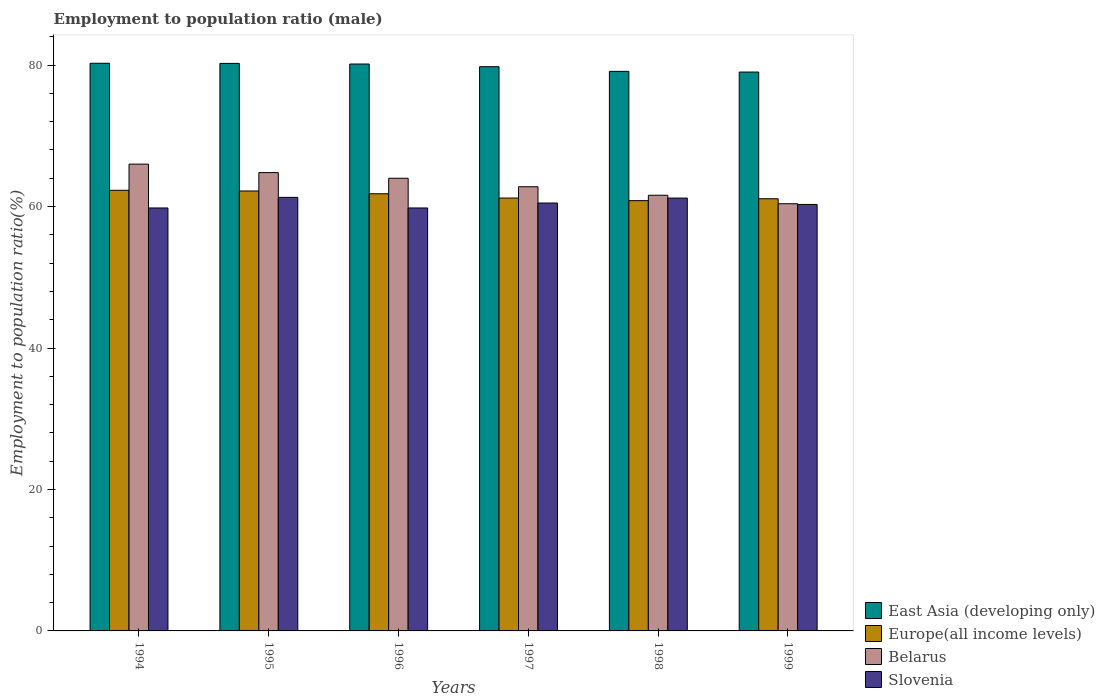How many different coloured bars are there?
Your response must be concise. 4. Are the number of bars per tick equal to the number of legend labels?
Provide a short and direct response. Yes. Are the number of bars on each tick of the X-axis equal?
Offer a terse response. Yes. How many bars are there on the 3rd tick from the left?
Make the answer very short. 4. How many bars are there on the 2nd tick from the right?
Offer a terse response. 4. What is the label of the 1st group of bars from the left?
Your response must be concise. 1994. In how many cases, is the number of bars for a given year not equal to the number of legend labels?
Give a very brief answer. 0. Across all years, what is the maximum employment to population ratio in East Asia (developing only)?
Provide a short and direct response. 80.26. Across all years, what is the minimum employment to population ratio in Belarus?
Provide a short and direct response. 60.4. In which year was the employment to population ratio in East Asia (developing only) maximum?
Offer a very short reply. 1994. What is the total employment to population ratio in Europe(all income levels) in the graph?
Provide a succinct answer. 369.45. What is the difference between the employment to population ratio in Europe(all income levels) in 1998 and that in 1999?
Offer a terse response. -0.27. What is the average employment to population ratio in Slovenia per year?
Keep it short and to the point. 60.48. In the year 1998, what is the difference between the employment to population ratio in Belarus and employment to population ratio in East Asia (developing only)?
Keep it short and to the point. -17.51. What is the ratio of the employment to population ratio in Slovenia in 1995 to that in 1996?
Keep it short and to the point. 1.03. Is the difference between the employment to population ratio in Belarus in 1996 and 1998 greater than the difference between the employment to population ratio in East Asia (developing only) in 1996 and 1998?
Make the answer very short. Yes. What is the difference between the highest and the second highest employment to population ratio in Europe(all income levels)?
Your response must be concise. 0.1. What is the difference between the highest and the lowest employment to population ratio in Belarus?
Make the answer very short. 5.6. In how many years, is the employment to population ratio in Europe(all income levels) greater than the average employment to population ratio in Europe(all income levels) taken over all years?
Ensure brevity in your answer.  3. Is the sum of the employment to population ratio in Europe(all income levels) in 1994 and 1996 greater than the maximum employment to population ratio in Slovenia across all years?
Offer a terse response. Yes. What does the 1st bar from the left in 1999 represents?
Provide a succinct answer. East Asia (developing only). What does the 2nd bar from the right in 1996 represents?
Give a very brief answer. Belarus. Is it the case that in every year, the sum of the employment to population ratio in East Asia (developing only) and employment to population ratio in Belarus is greater than the employment to population ratio in Europe(all income levels)?
Your answer should be very brief. Yes. Are all the bars in the graph horizontal?
Offer a very short reply. No. How many years are there in the graph?
Your response must be concise. 6. What is the difference between two consecutive major ticks on the Y-axis?
Your answer should be compact. 20. Where does the legend appear in the graph?
Offer a terse response. Bottom right. How many legend labels are there?
Ensure brevity in your answer.  4. What is the title of the graph?
Give a very brief answer. Employment to population ratio (male). Does "Papua New Guinea" appear as one of the legend labels in the graph?
Your response must be concise. No. What is the label or title of the X-axis?
Keep it short and to the point. Years. What is the Employment to population ratio(%) of East Asia (developing only) in 1994?
Your answer should be very brief. 80.26. What is the Employment to population ratio(%) of Europe(all income levels) in 1994?
Offer a very short reply. 62.3. What is the Employment to population ratio(%) of Belarus in 1994?
Provide a succinct answer. 66. What is the Employment to population ratio(%) of Slovenia in 1994?
Your response must be concise. 59.8. What is the Employment to population ratio(%) of East Asia (developing only) in 1995?
Keep it short and to the point. 80.24. What is the Employment to population ratio(%) of Europe(all income levels) in 1995?
Offer a very short reply. 62.2. What is the Employment to population ratio(%) of Belarus in 1995?
Your response must be concise. 64.8. What is the Employment to population ratio(%) in Slovenia in 1995?
Ensure brevity in your answer.  61.3. What is the Employment to population ratio(%) in East Asia (developing only) in 1996?
Your response must be concise. 80.15. What is the Employment to population ratio(%) of Europe(all income levels) in 1996?
Give a very brief answer. 61.81. What is the Employment to population ratio(%) in Belarus in 1996?
Offer a very short reply. 64. What is the Employment to population ratio(%) of Slovenia in 1996?
Your answer should be very brief. 59.8. What is the Employment to population ratio(%) of East Asia (developing only) in 1997?
Offer a terse response. 79.78. What is the Employment to population ratio(%) of Europe(all income levels) in 1997?
Your response must be concise. 61.2. What is the Employment to population ratio(%) of Belarus in 1997?
Offer a very short reply. 62.8. What is the Employment to population ratio(%) of Slovenia in 1997?
Your answer should be very brief. 60.5. What is the Employment to population ratio(%) in East Asia (developing only) in 1998?
Your answer should be very brief. 79.11. What is the Employment to population ratio(%) in Europe(all income levels) in 1998?
Offer a terse response. 60.83. What is the Employment to population ratio(%) in Belarus in 1998?
Offer a terse response. 61.6. What is the Employment to population ratio(%) in Slovenia in 1998?
Make the answer very short. 61.2. What is the Employment to population ratio(%) in East Asia (developing only) in 1999?
Make the answer very short. 79.02. What is the Employment to population ratio(%) in Europe(all income levels) in 1999?
Make the answer very short. 61.1. What is the Employment to population ratio(%) in Belarus in 1999?
Keep it short and to the point. 60.4. What is the Employment to population ratio(%) in Slovenia in 1999?
Offer a terse response. 60.3. Across all years, what is the maximum Employment to population ratio(%) of East Asia (developing only)?
Give a very brief answer. 80.26. Across all years, what is the maximum Employment to population ratio(%) of Europe(all income levels)?
Make the answer very short. 62.3. Across all years, what is the maximum Employment to population ratio(%) of Belarus?
Provide a short and direct response. 66. Across all years, what is the maximum Employment to population ratio(%) of Slovenia?
Offer a very short reply. 61.3. Across all years, what is the minimum Employment to population ratio(%) of East Asia (developing only)?
Your answer should be very brief. 79.02. Across all years, what is the minimum Employment to population ratio(%) of Europe(all income levels)?
Make the answer very short. 60.83. Across all years, what is the minimum Employment to population ratio(%) in Belarus?
Keep it short and to the point. 60.4. Across all years, what is the minimum Employment to population ratio(%) in Slovenia?
Your response must be concise. 59.8. What is the total Employment to population ratio(%) in East Asia (developing only) in the graph?
Offer a very short reply. 478.56. What is the total Employment to population ratio(%) of Europe(all income levels) in the graph?
Provide a short and direct response. 369.45. What is the total Employment to population ratio(%) in Belarus in the graph?
Ensure brevity in your answer.  379.6. What is the total Employment to population ratio(%) in Slovenia in the graph?
Your response must be concise. 362.9. What is the difference between the Employment to population ratio(%) in East Asia (developing only) in 1994 and that in 1995?
Your answer should be compact. 0.02. What is the difference between the Employment to population ratio(%) in Europe(all income levels) in 1994 and that in 1995?
Make the answer very short. 0.1. What is the difference between the Employment to population ratio(%) in Slovenia in 1994 and that in 1995?
Make the answer very short. -1.5. What is the difference between the Employment to population ratio(%) in East Asia (developing only) in 1994 and that in 1996?
Provide a short and direct response. 0.11. What is the difference between the Employment to population ratio(%) in Europe(all income levels) in 1994 and that in 1996?
Provide a short and direct response. 0.49. What is the difference between the Employment to population ratio(%) of East Asia (developing only) in 1994 and that in 1997?
Give a very brief answer. 0.48. What is the difference between the Employment to population ratio(%) of Europe(all income levels) in 1994 and that in 1997?
Make the answer very short. 1.1. What is the difference between the Employment to population ratio(%) in Belarus in 1994 and that in 1997?
Your answer should be compact. 3.2. What is the difference between the Employment to population ratio(%) of East Asia (developing only) in 1994 and that in 1998?
Offer a terse response. 1.15. What is the difference between the Employment to population ratio(%) in Europe(all income levels) in 1994 and that in 1998?
Ensure brevity in your answer.  1.47. What is the difference between the Employment to population ratio(%) in Belarus in 1994 and that in 1998?
Ensure brevity in your answer.  4.4. What is the difference between the Employment to population ratio(%) of Slovenia in 1994 and that in 1998?
Your answer should be compact. -1.4. What is the difference between the Employment to population ratio(%) of East Asia (developing only) in 1994 and that in 1999?
Provide a succinct answer. 1.24. What is the difference between the Employment to population ratio(%) in Europe(all income levels) in 1994 and that in 1999?
Keep it short and to the point. 1.2. What is the difference between the Employment to population ratio(%) in East Asia (developing only) in 1995 and that in 1996?
Ensure brevity in your answer.  0.09. What is the difference between the Employment to population ratio(%) in Europe(all income levels) in 1995 and that in 1996?
Offer a very short reply. 0.39. What is the difference between the Employment to population ratio(%) of Slovenia in 1995 and that in 1996?
Make the answer very short. 1.5. What is the difference between the Employment to population ratio(%) of East Asia (developing only) in 1995 and that in 1997?
Give a very brief answer. 0.46. What is the difference between the Employment to population ratio(%) of Europe(all income levels) in 1995 and that in 1997?
Provide a succinct answer. 1. What is the difference between the Employment to population ratio(%) in East Asia (developing only) in 1995 and that in 1998?
Offer a terse response. 1.13. What is the difference between the Employment to population ratio(%) in Europe(all income levels) in 1995 and that in 1998?
Offer a very short reply. 1.37. What is the difference between the Employment to population ratio(%) in Slovenia in 1995 and that in 1998?
Keep it short and to the point. 0.1. What is the difference between the Employment to population ratio(%) in East Asia (developing only) in 1995 and that in 1999?
Give a very brief answer. 1.22. What is the difference between the Employment to population ratio(%) in Europe(all income levels) in 1995 and that in 1999?
Your response must be concise. 1.1. What is the difference between the Employment to population ratio(%) in Belarus in 1995 and that in 1999?
Offer a very short reply. 4.4. What is the difference between the Employment to population ratio(%) of East Asia (developing only) in 1996 and that in 1997?
Ensure brevity in your answer.  0.38. What is the difference between the Employment to population ratio(%) in Europe(all income levels) in 1996 and that in 1997?
Provide a succinct answer. 0.61. What is the difference between the Employment to population ratio(%) in East Asia (developing only) in 1996 and that in 1998?
Provide a succinct answer. 1.04. What is the difference between the Employment to population ratio(%) of Europe(all income levels) in 1996 and that in 1998?
Your response must be concise. 0.97. What is the difference between the Employment to population ratio(%) in East Asia (developing only) in 1996 and that in 1999?
Your answer should be very brief. 1.14. What is the difference between the Employment to population ratio(%) of Europe(all income levels) in 1996 and that in 1999?
Your answer should be compact. 0.71. What is the difference between the Employment to population ratio(%) of Belarus in 1996 and that in 1999?
Make the answer very short. 3.6. What is the difference between the Employment to population ratio(%) of East Asia (developing only) in 1997 and that in 1998?
Your answer should be compact. 0.66. What is the difference between the Employment to population ratio(%) of Europe(all income levels) in 1997 and that in 1998?
Offer a very short reply. 0.37. What is the difference between the Employment to population ratio(%) in Belarus in 1997 and that in 1998?
Keep it short and to the point. 1.2. What is the difference between the Employment to population ratio(%) of East Asia (developing only) in 1997 and that in 1999?
Keep it short and to the point. 0.76. What is the difference between the Employment to population ratio(%) of Europe(all income levels) in 1997 and that in 1999?
Provide a short and direct response. 0.1. What is the difference between the Employment to population ratio(%) in Belarus in 1997 and that in 1999?
Your answer should be compact. 2.4. What is the difference between the Employment to population ratio(%) of Slovenia in 1997 and that in 1999?
Your answer should be very brief. 0.2. What is the difference between the Employment to population ratio(%) in East Asia (developing only) in 1998 and that in 1999?
Provide a short and direct response. 0.1. What is the difference between the Employment to population ratio(%) in Europe(all income levels) in 1998 and that in 1999?
Offer a very short reply. -0.27. What is the difference between the Employment to population ratio(%) in Slovenia in 1998 and that in 1999?
Keep it short and to the point. 0.9. What is the difference between the Employment to population ratio(%) in East Asia (developing only) in 1994 and the Employment to population ratio(%) in Europe(all income levels) in 1995?
Your answer should be very brief. 18.06. What is the difference between the Employment to population ratio(%) in East Asia (developing only) in 1994 and the Employment to population ratio(%) in Belarus in 1995?
Offer a terse response. 15.46. What is the difference between the Employment to population ratio(%) in East Asia (developing only) in 1994 and the Employment to population ratio(%) in Slovenia in 1995?
Offer a very short reply. 18.96. What is the difference between the Employment to population ratio(%) in Europe(all income levels) in 1994 and the Employment to population ratio(%) in Belarus in 1995?
Your answer should be compact. -2.5. What is the difference between the Employment to population ratio(%) of Europe(all income levels) in 1994 and the Employment to population ratio(%) of Slovenia in 1995?
Offer a very short reply. 1. What is the difference between the Employment to population ratio(%) in East Asia (developing only) in 1994 and the Employment to population ratio(%) in Europe(all income levels) in 1996?
Keep it short and to the point. 18.45. What is the difference between the Employment to population ratio(%) in East Asia (developing only) in 1994 and the Employment to population ratio(%) in Belarus in 1996?
Offer a terse response. 16.26. What is the difference between the Employment to population ratio(%) in East Asia (developing only) in 1994 and the Employment to population ratio(%) in Slovenia in 1996?
Your response must be concise. 20.46. What is the difference between the Employment to population ratio(%) in Europe(all income levels) in 1994 and the Employment to population ratio(%) in Belarus in 1996?
Keep it short and to the point. -1.7. What is the difference between the Employment to population ratio(%) in Europe(all income levels) in 1994 and the Employment to population ratio(%) in Slovenia in 1996?
Provide a succinct answer. 2.5. What is the difference between the Employment to population ratio(%) of East Asia (developing only) in 1994 and the Employment to population ratio(%) of Europe(all income levels) in 1997?
Keep it short and to the point. 19.06. What is the difference between the Employment to population ratio(%) in East Asia (developing only) in 1994 and the Employment to population ratio(%) in Belarus in 1997?
Offer a very short reply. 17.46. What is the difference between the Employment to population ratio(%) of East Asia (developing only) in 1994 and the Employment to population ratio(%) of Slovenia in 1997?
Offer a terse response. 19.76. What is the difference between the Employment to population ratio(%) of Europe(all income levels) in 1994 and the Employment to population ratio(%) of Belarus in 1997?
Your answer should be very brief. -0.5. What is the difference between the Employment to population ratio(%) of Europe(all income levels) in 1994 and the Employment to population ratio(%) of Slovenia in 1997?
Provide a short and direct response. 1.8. What is the difference between the Employment to population ratio(%) in East Asia (developing only) in 1994 and the Employment to population ratio(%) in Europe(all income levels) in 1998?
Give a very brief answer. 19.43. What is the difference between the Employment to population ratio(%) of East Asia (developing only) in 1994 and the Employment to population ratio(%) of Belarus in 1998?
Your answer should be compact. 18.66. What is the difference between the Employment to population ratio(%) of East Asia (developing only) in 1994 and the Employment to population ratio(%) of Slovenia in 1998?
Offer a very short reply. 19.06. What is the difference between the Employment to population ratio(%) of Europe(all income levels) in 1994 and the Employment to population ratio(%) of Belarus in 1998?
Give a very brief answer. 0.7. What is the difference between the Employment to population ratio(%) of Europe(all income levels) in 1994 and the Employment to population ratio(%) of Slovenia in 1998?
Make the answer very short. 1.1. What is the difference between the Employment to population ratio(%) of Belarus in 1994 and the Employment to population ratio(%) of Slovenia in 1998?
Provide a succinct answer. 4.8. What is the difference between the Employment to population ratio(%) in East Asia (developing only) in 1994 and the Employment to population ratio(%) in Europe(all income levels) in 1999?
Offer a very short reply. 19.16. What is the difference between the Employment to population ratio(%) in East Asia (developing only) in 1994 and the Employment to population ratio(%) in Belarus in 1999?
Your answer should be very brief. 19.86. What is the difference between the Employment to population ratio(%) of East Asia (developing only) in 1994 and the Employment to population ratio(%) of Slovenia in 1999?
Provide a short and direct response. 19.96. What is the difference between the Employment to population ratio(%) in Europe(all income levels) in 1994 and the Employment to population ratio(%) in Belarus in 1999?
Make the answer very short. 1.9. What is the difference between the Employment to population ratio(%) in Europe(all income levels) in 1994 and the Employment to population ratio(%) in Slovenia in 1999?
Provide a succinct answer. 2. What is the difference between the Employment to population ratio(%) of East Asia (developing only) in 1995 and the Employment to population ratio(%) of Europe(all income levels) in 1996?
Make the answer very short. 18.43. What is the difference between the Employment to population ratio(%) of East Asia (developing only) in 1995 and the Employment to population ratio(%) of Belarus in 1996?
Your answer should be compact. 16.24. What is the difference between the Employment to population ratio(%) of East Asia (developing only) in 1995 and the Employment to population ratio(%) of Slovenia in 1996?
Your answer should be very brief. 20.44. What is the difference between the Employment to population ratio(%) of Europe(all income levels) in 1995 and the Employment to population ratio(%) of Belarus in 1996?
Your response must be concise. -1.8. What is the difference between the Employment to population ratio(%) in Europe(all income levels) in 1995 and the Employment to population ratio(%) in Slovenia in 1996?
Your answer should be compact. 2.4. What is the difference between the Employment to population ratio(%) of Belarus in 1995 and the Employment to population ratio(%) of Slovenia in 1996?
Keep it short and to the point. 5. What is the difference between the Employment to population ratio(%) of East Asia (developing only) in 1995 and the Employment to population ratio(%) of Europe(all income levels) in 1997?
Your response must be concise. 19.04. What is the difference between the Employment to population ratio(%) in East Asia (developing only) in 1995 and the Employment to population ratio(%) in Belarus in 1997?
Offer a very short reply. 17.44. What is the difference between the Employment to population ratio(%) in East Asia (developing only) in 1995 and the Employment to population ratio(%) in Slovenia in 1997?
Give a very brief answer. 19.74. What is the difference between the Employment to population ratio(%) of Europe(all income levels) in 1995 and the Employment to population ratio(%) of Belarus in 1997?
Give a very brief answer. -0.6. What is the difference between the Employment to population ratio(%) of Europe(all income levels) in 1995 and the Employment to population ratio(%) of Slovenia in 1997?
Your answer should be compact. 1.7. What is the difference between the Employment to population ratio(%) of East Asia (developing only) in 1995 and the Employment to population ratio(%) of Europe(all income levels) in 1998?
Ensure brevity in your answer.  19.4. What is the difference between the Employment to population ratio(%) in East Asia (developing only) in 1995 and the Employment to population ratio(%) in Belarus in 1998?
Your answer should be compact. 18.64. What is the difference between the Employment to population ratio(%) of East Asia (developing only) in 1995 and the Employment to population ratio(%) of Slovenia in 1998?
Your answer should be very brief. 19.04. What is the difference between the Employment to population ratio(%) of Europe(all income levels) in 1995 and the Employment to population ratio(%) of Belarus in 1998?
Provide a short and direct response. 0.6. What is the difference between the Employment to population ratio(%) in Belarus in 1995 and the Employment to population ratio(%) in Slovenia in 1998?
Your answer should be compact. 3.6. What is the difference between the Employment to population ratio(%) in East Asia (developing only) in 1995 and the Employment to population ratio(%) in Europe(all income levels) in 1999?
Offer a very short reply. 19.14. What is the difference between the Employment to population ratio(%) of East Asia (developing only) in 1995 and the Employment to population ratio(%) of Belarus in 1999?
Offer a terse response. 19.84. What is the difference between the Employment to population ratio(%) of East Asia (developing only) in 1995 and the Employment to population ratio(%) of Slovenia in 1999?
Offer a very short reply. 19.94. What is the difference between the Employment to population ratio(%) of Europe(all income levels) in 1995 and the Employment to population ratio(%) of Belarus in 1999?
Your response must be concise. 1.8. What is the difference between the Employment to population ratio(%) in Europe(all income levels) in 1995 and the Employment to population ratio(%) in Slovenia in 1999?
Provide a succinct answer. 1.9. What is the difference between the Employment to population ratio(%) of Belarus in 1995 and the Employment to population ratio(%) of Slovenia in 1999?
Offer a terse response. 4.5. What is the difference between the Employment to population ratio(%) of East Asia (developing only) in 1996 and the Employment to population ratio(%) of Europe(all income levels) in 1997?
Provide a short and direct response. 18.95. What is the difference between the Employment to population ratio(%) of East Asia (developing only) in 1996 and the Employment to population ratio(%) of Belarus in 1997?
Give a very brief answer. 17.35. What is the difference between the Employment to population ratio(%) in East Asia (developing only) in 1996 and the Employment to population ratio(%) in Slovenia in 1997?
Offer a terse response. 19.65. What is the difference between the Employment to population ratio(%) of Europe(all income levels) in 1996 and the Employment to population ratio(%) of Belarus in 1997?
Keep it short and to the point. -0.99. What is the difference between the Employment to population ratio(%) of Europe(all income levels) in 1996 and the Employment to population ratio(%) of Slovenia in 1997?
Ensure brevity in your answer.  1.31. What is the difference between the Employment to population ratio(%) in Belarus in 1996 and the Employment to population ratio(%) in Slovenia in 1997?
Provide a short and direct response. 3.5. What is the difference between the Employment to population ratio(%) of East Asia (developing only) in 1996 and the Employment to population ratio(%) of Europe(all income levels) in 1998?
Your answer should be compact. 19.32. What is the difference between the Employment to population ratio(%) of East Asia (developing only) in 1996 and the Employment to population ratio(%) of Belarus in 1998?
Give a very brief answer. 18.55. What is the difference between the Employment to population ratio(%) in East Asia (developing only) in 1996 and the Employment to population ratio(%) in Slovenia in 1998?
Ensure brevity in your answer.  18.95. What is the difference between the Employment to population ratio(%) of Europe(all income levels) in 1996 and the Employment to population ratio(%) of Belarus in 1998?
Make the answer very short. 0.21. What is the difference between the Employment to population ratio(%) in Europe(all income levels) in 1996 and the Employment to population ratio(%) in Slovenia in 1998?
Your response must be concise. 0.61. What is the difference between the Employment to population ratio(%) of East Asia (developing only) in 1996 and the Employment to population ratio(%) of Europe(all income levels) in 1999?
Offer a very short reply. 19.05. What is the difference between the Employment to population ratio(%) of East Asia (developing only) in 1996 and the Employment to population ratio(%) of Belarus in 1999?
Your response must be concise. 19.75. What is the difference between the Employment to population ratio(%) of East Asia (developing only) in 1996 and the Employment to population ratio(%) of Slovenia in 1999?
Your answer should be very brief. 19.85. What is the difference between the Employment to population ratio(%) in Europe(all income levels) in 1996 and the Employment to population ratio(%) in Belarus in 1999?
Your answer should be very brief. 1.41. What is the difference between the Employment to population ratio(%) of Europe(all income levels) in 1996 and the Employment to population ratio(%) of Slovenia in 1999?
Keep it short and to the point. 1.51. What is the difference between the Employment to population ratio(%) of East Asia (developing only) in 1997 and the Employment to population ratio(%) of Europe(all income levels) in 1998?
Your answer should be compact. 18.94. What is the difference between the Employment to population ratio(%) in East Asia (developing only) in 1997 and the Employment to population ratio(%) in Belarus in 1998?
Ensure brevity in your answer.  18.18. What is the difference between the Employment to population ratio(%) of East Asia (developing only) in 1997 and the Employment to population ratio(%) of Slovenia in 1998?
Keep it short and to the point. 18.58. What is the difference between the Employment to population ratio(%) of Europe(all income levels) in 1997 and the Employment to population ratio(%) of Belarus in 1998?
Make the answer very short. -0.4. What is the difference between the Employment to population ratio(%) of Europe(all income levels) in 1997 and the Employment to population ratio(%) of Slovenia in 1998?
Give a very brief answer. 0. What is the difference between the Employment to population ratio(%) in Belarus in 1997 and the Employment to population ratio(%) in Slovenia in 1998?
Provide a succinct answer. 1.6. What is the difference between the Employment to population ratio(%) in East Asia (developing only) in 1997 and the Employment to population ratio(%) in Europe(all income levels) in 1999?
Offer a very short reply. 18.67. What is the difference between the Employment to population ratio(%) in East Asia (developing only) in 1997 and the Employment to population ratio(%) in Belarus in 1999?
Give a very brief answer. 19.38. What is the difference between the Employment to population ratio(%) in East Asia (developing only) in 1997 and the Employment to population ratio(%) in Slovenia in 1999?
Your response must be concise. 19.48. What is the difference between the Employment to population ratio(%) in Europe(all income levels) in 1997 and the Employment to population ratio(%) in Belarus in 1999?
Your answer should be compact. 0.8. What is the difference between the Employment to population ratio(%) in Europe(all income levels) in 1997 and the Employment to population ratio(%) in Slovenia in 1999?
Make the answer very short. 0.9. What is the difference between the Employment to population ratio(%) of Belarus in 1997 and the Employment to population ratio(%) of Slovenia in 1999?
Provide a succinct answer. 2.5. What is the difference between the Employment to population ratio(%) of East Asia (developing only) in 1998 and the Employment to population ratio(%) of Europe(all income levels) in 1999?
Offer a very short reply. 18.01. What is the difference between the Employment to population ratio(%) in East Asia (developing only) in 1998 and the Employment to population ratio(%) in Belarus in 1999?
Provide a succinct answer. 18.71. What is the difference between the Employment to population ratio(%) of East Asia (developing only) in 1998 and the Employment to population ratio(%) of Slovenia in 1999?
Give a very brief answer. 18.81. What is the difference between the Employment to population ratio(%) in Europe(all income levels) in 1998 and the Employment to population ratio(%) in Belarus in 1999?
Offer a terse response. 0.43. What is the difference between the Employment to population ratio(%) of Europe(all income levels) in 1998 and the Employment to population ratio(%) of Slovenia in 1999?
Provide a succinct answer. 0.53. What is the average Employment to population ratio(%) in East Asia (developing only) per year?
Your response must be concise. 79.76. What is the average Employment to population ratio(%) in Europe(all income levels) per year?
Ensure brevity in your answer.  61.58. What is the average Employment to population ratio(%) of Belarus per year?
Your answer should be very brief. 63.27. What is the average Employment to population ratio(%) of Slovenia per year?
Give a very brief answer. 60.48. In the year 1994, what is the difference between the Employment to population ratio(%) of East Asia (developing only) and Employment to population ratio(%) of Europe(all income levels)?
Offer a very short reply. 17.96. In the year 1994, what is the difference between the Employment to population ratio(%) in East Asia (developing only) and Employment to population ratio(%) in Belarus?
Your response must be concise. 14.26. In the year 1994, what is the difference between the Employment to population ratio(%) in East Asia (developing only) and Employment to population ratio(%) in Slovenia?
Your answer should be very brief. 20.46. In the year 1994, what is the difference between the Employment to population ratio(%) in Europe(all income levels) and Employment to population ratio(%) in Belarus?
Your response must be concise. -3.7. In the year 1994, what is the difference between the Employment to population ratio(%) of Europe(all income levels) and Employment to population ratio(%) of Slovenia?
Offer a terse response. 2.5. In the year 1995, what is the difference between the Employment to population ratio(%) of East Asia (developing only) and Employment to population ratio(%) of Europe(all income levels)?
Provide a short and direct response. 18.04. In the year 1995, what is the difference between the Employment to population ratio(%) of East Asia (developing only) and Employment to population ratio(%) of Belarus?
Make the answer very short. 15.44. In the year 1995, what is the difference between the Employment to population ratio(%) of East Asia (developing only) and Employment to population ratio(%) of Slovenia?
Offer a very short reply. 18.94. In the year 1995, what is the difference between the Employment to population ratio(%) of Europe(all income levels) and Employment to population ratio(%) of Belarus?
Your answer should be very brief. -2.6. In the year 1995, what is the difference between the Employment to population ratio(%) in Europe(all income levels) and Employment to population ratio(%) in Slovenia?
Keep it short and to the point. 0.9. In the year 1995, what is the difference between the Employment to population ratio(%) of Belarus and Employment to population ratio(%) of Slovenia?
Keep it short and to the point. 3.5. In the year 1996, what is the difference between the Employment to population ratio(%) of East Asia (developing only) and Employment to population ratio(%) of Europe(all income levels)?
Offer a terse response. 18.34. In the year 1996, what is the difference between the Employment to population ratio(%) in East Asia (developing only) and Employment to population ratio(%) in Belarus?
Provide a short and direct response. 16.15. In the year 1996, what is the difference between the Employment to population ratio(%) in East Asia (developing only) and Employment to population ratio(%) in Slovenia?
Provide a short and direct response. 20.35. In the year 1996, what is the difference between the Employment to population ratio(%) of Europe(all income levels) and Employment to population ratio(%) of Belarus?
Your response must be concise. -2.19. In the year 1996, what is the difference between the Employment to population ratio(%) of Europe(all income levels) and Employment to population ratio(%) of Slovenia?
Make the answer very short. 2.01. In the year 1997, what is the difference between the Employment to population ratio(%) in East Asia (developing only) and Employment to population ratio(%) in Europe(all income levels)?
Give a very brief answer. 18.57. In the year 1997, what is the difference between the Employment to population ratio(%) of East Asia (developing only) and Employment to population ratio(%) of Belarus?
Offer a very short reply. 16.98. In the year 1997, what is the difference between the Employment to population ratio(%) in East Asia (developing only) and Employment to population ratio(%) in Slovenia?
Offer a very short reply. 19.28. In the year 1997, what is the difference between the Employment to population ratio(%) of Europe(all income levels) and Employment to population ratio(%) of Belarus?
Offer a very short reply. -1.6. In the year 1997, what is the difference between the Employment to population ratio(%) in Europe(all income levels) and Employment to population ratio(%) in Slovenia?
Your answer should be very brief. 0.7. In the year 1998, what is the difference between the Employment to population ratio(%) of East Asia (developing only) and Employment to population ratio(%) of Europe(all income levels)?
Your answer should be very brief. 18.28. In the year 1998, what is the difference between the Employment to population ratio(%) of East Asia (developing only) and Employment to population ratio(%) of Belarus?
Provide a short and direct response. 17.51. In the year 1998, what is the difference between the Employment to population ratio(%) of East Asia (developing only) and Employment to population ratio(%) of Slovenia?
Your answer should be very brief. 17.91. In the year 1998, what is the difference between the Employment to population ratio(%) in Europe(all income levels) and Employment to population ratio(%) in Belarus?
Make the answer very short. -0.77. In the year 1998, what is the difference between the Employment to population ratio(%) of Europe(all income levels) and Employment to population ratio(%) of Slovenia?
Your answer should be compact. -0.37. In the year 1998, what is the difference between the Employment to population ratio(%) of Belarus and Employment to population ratio(%) of Slovenia?
Ensure brevity in your answer.  0.4. In the year 1999, what is the difference between the Employment to population ratio(%) of East Asia (developing only) and Employment to population ratio(%) of Europe(all income levels)?
Give a very brief answer. 17.91. In the year 1999, what is the difference between the Employment to population ratio(%) in East Asia (developing only) and Employment to population ratio(%) in Belarus?
Provide a succinct answer. 18.62. In the year 1999, what is the difference between the Employment to population ratio(%) of East Asia (developing only) and Employment to population ratio(%) of Slovenia?
Your answer should be very brief. 18.72. In the year 1999, what is the difference between the Employment to population ratio(%) in Europe(all income levels) and Employment to population ratio(%) in Belarus?
Your answer should be very brief. 0.7. In the year 1999, what is the difference between the Employment to population ratio(%) in Europe(all income levels) and Employment to population ratio(%) in Slovenia?
Your answer should be compact. 0.8. What is the ratio of the Employment to population ratio(%) in Belarus in 1994 to that in 1995?
Offer a terse response. 1.02. What is the ratio of the Employment to population ratio(%) in Slovenia in 1994 to that in 1995?
Your answer should be compact. 0.98. What is the ratio of the Employment to population ratio(%) of Europe(all income levels) in 1994 to that in 1996?
Your response must be concise. 1.01. What is the ratio of the Employment to population ratio(%) of Belarus in 1994 to that in 1996?
Offer a terse response. 1.03. What is the ratio of the Employment to population ratio(%) in Slovenia in 1994 to that in 1996?
Make the answer very short. 1. What is the ratio of the Employment to population ratio(%) of East Asia (developing only) in 1994 to that in 1997?
Keep it short and to the point. 1.01. What is the ratio of the Employment to population ratio(%) of Europe(all income levels) in 1994 to that in 1997?
Ensure brevity in your answer.  1.02. What is the ratio of the Employment to population ratio(%) of Belarus in 1994 to that in 1997?
Your response must be concise. 1.05. What is the ratio of the Employment to population ratio(%) of Slovenia in 1994 to that in 1997?
Offer a very short reply. 0.99. What is the ratio of the Employment to population ratio(%) of East Asia (developing only) in 1994 to that in 1998?
Make the answer very short. 1.01. What is the ratio of the Employment to population ratio(%) of Europe(all income levels) in 1994 to that in 1998?
Your answer should be compact. 1.02. What is the ratio of the Employment to population ratio(%) in Belarus in 1994 to that in 1998?
Offer a very short reply. 1.07. What is the ratio of the Employment to population ratio(%) of Slovenia in 1994 to that in 1998?
Your response must be concise. 0.98. What is the ratio of the Employment to population ratio(%) of East Asia (developing only) in 1994 to that in 1999?
Provide a short and direct response. 1.02. What is the ratio of the Employment to population ratio(%) in Europe(all income levels) in 1994 to that in 1999?
Offer a very short reply. 1.02. What is the ratio of the Employment to population ratio(%) in Belarus in 1994 to that in 1999?
Keep it short and to the point. 1.09. What is the ratio of the Employment to population ratio(%) of Slovenia in 1994 to that in 1999?
Provide a succinct answer. 0.99. What is the ratio of the Employment to population ratio(%) in East Asia (developing only) in 1995 to that in 1996?
Your answer should be compact. 1. What is the ratio of the Employment to population ratio(%) in Europe(all income levels) in 1995 to that in 1996?
Ensure brevity in your answer.  1.01. What is the ratio of the Employment to population ratio(%) in Belarus in 1995 to that in 1996?
Your response must be concise. 1.01. What is the ratio of the Employment to population ratio(%) in Slovenia in 1995 to that in 1996?
Make the answer very short. 1.03. What is the ratio of the Employment to population ratio(%) in Europe(all income levels) in 1995 to that in 1997?
Ensure brevity in your answer.  1.02. What is the ratio of the Employment to population ratio(%) in Belarus in 1995 to that in 1997?
Provide a short and direct response. 1.03. What is the ratio of the Employment to population ratio(%) of Slovenia in 1995 to that in 1997?
Provide a succinct answer. 1.01. What is the ratio of the Employment to population ratio(%) in East Asia (developing only) in 1995 to that in 1998?
Provide a succinct answer. 1.01. What is the ratio of the Employment to population ratio(%) in Europe(all income levels) in 1995 to that in 1998?
Your answer should be compact. 1.02. What is the ratio of the Employment to population ratio(%) of Belarus in 1995 to that in 1998?
Make the answer very short. 1.05. What is the ratio of the Employment to population ratio(%) in East Asia (developing only) in 1995 to that in 1999?
Ensure brevity in your answer.  1.02. What is the ratio of the Employment to population ratio(%) of Europe(all income levels) in 1995 to that in 1999?
Provide a short and direct response. 1.02. What is the ratio of the Employment to population ratio(%) of Belarus in 1995 to that in 1999?
Provide a short and direct response. 1.07. What is the ratio of the Employment to population ratio(%) of Slovenia in 1995 to that in 1999?
Offer a terse response. 1.02. What is the ratio of the Employment to population ratio(%) in Europe(all income levels) in 1996 to that in 1997?
Offer a very short reply. 1.01. What is the ratio of the Employment to population ratio(%) in Belarus in 1996 to that in 1997?
Your response must be concise. 1.02. What is the ratio of the Employment to population ratio(%) of Slovenia in 1996 to that in 1997?
Offer a very short reply. 0.99. What is the ratio of the Employment to population ratio(%) of East Asia (developing only) in 1996 to that in 1998?
Ensure brevity in your answer.  1.01. What is the ratio of the Employment to population ratio(%) of Belarus in 1996 to that in 1998?
Your answer should be compact. 1.04. What is the ratio of the Employment to population ratio(%) of Slovenia in 1996 to that in 1998?
Keep it short and to the point. 0.98. What is the ratio of the Employment to population ratio(%) in East Asia (developing only) in 1996 to that in 1999?
Give a very brief answer. 1.01. What is the ratio of the Employment to population ratio(%) in Europe(all income levels) in 1996 to that in 1999?
Keep it short and to the point. 1.01. What is the ratio of the Employment to population ratio(%) in Belarus in 1996 to that in 1999?
Provide a short and direct response. 1.06. What is the ratio of the Employment to population ratio(%) in East Asia (developing only) in 1997 to that in 1998?
Your answer should be compact. 1.01. What is the ratio of the Employment to population ratio(%) of Belarus in 1997 to that in 1998?
Give a very brief answer. 1.02. What is the ratio of the Employment to population ratio(%) in East Asia (developing only) in 1997 to that in 1999?
Your answer should be very brief. 1.01. What is the ratio of the Employment to population ratio(%) of Europe(all income levels) in 1997 to that in 1999?
Provide a succinct answer. 1. What is the ratio of the Employment to population ratio(%) in Belarus in 1997 to that in 1999?
Offer a very short reply. 1.04. What is the ratio of the Employment to population ratio(%) in Slovenia in 1997 to that in 1999?
Your answer should be compact. 1. What is the ratio of the Employment to population ratio(%) of Europe(all income levels) in 1998 to that in 1999?
Your answer should be very brief. 1. What is the ratio of the Employment to population ratio(%) in Belarus in 1998 to that in 1999?
Offer a terse response. 1.02. What is the ratio of the Employment to population ratio(%) in Slovenia in 1998 to that in 1999?
Offer a very short reply. 1.01. What is the difference between the highest and the second highest Employment to population ratio(%) of East Asia (developing only)?
Your answer should be compact. 0.02. What is the difference between the highest and the second highest Employment to population ratio(%) in Europe(all income levels)?
Provide a succinct answer. 0.1. What is the difference between the highest and the second highest Employment to population ratio(%) in Belarus?
Provide a short and direct response. 1.2. What is the difference between the highest and the lowest Employment to population ratio(%) of East Asia (developing only)?
Give a very brief answer. 1.24. What is the difference between the highest and the lowest Employment to population ratio(%) in Europe(all income levels)?
Keep it short and to the point. 1.47. 